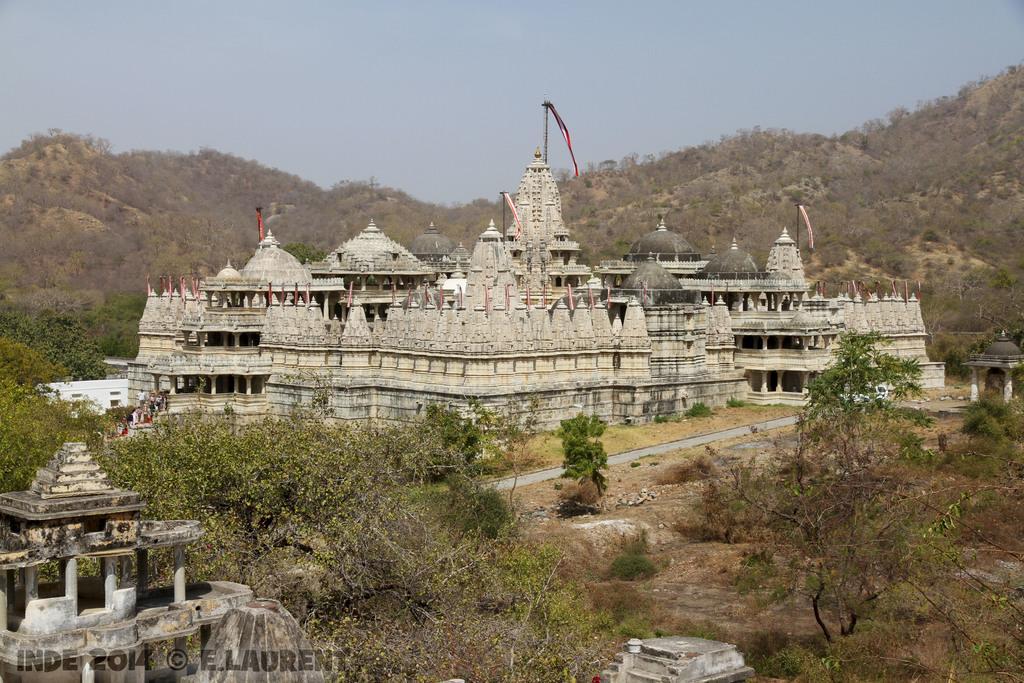Can you describe this image briefly? In this image I can see the temple which is in white and grey cor. In-front of the temple I can see many trees. To the left I can see one more temple. In the back I can see the mountains and the blue sky. 